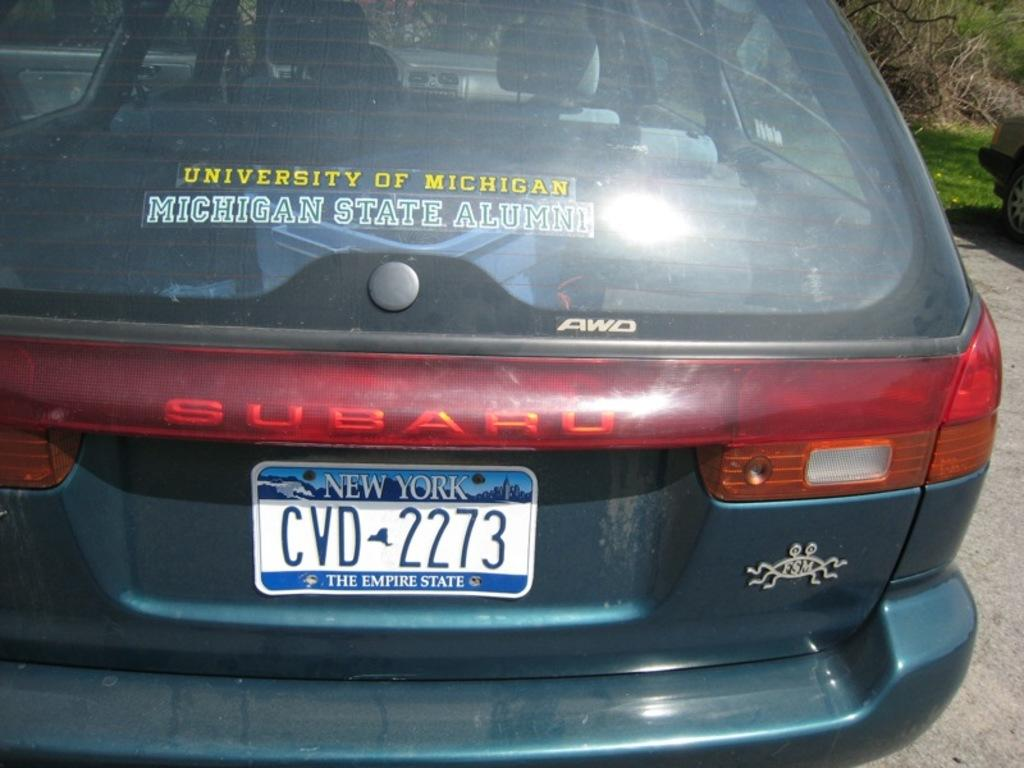<image>
Provide a brief description of the given image. The back of a car with a University of Michigan sticker 